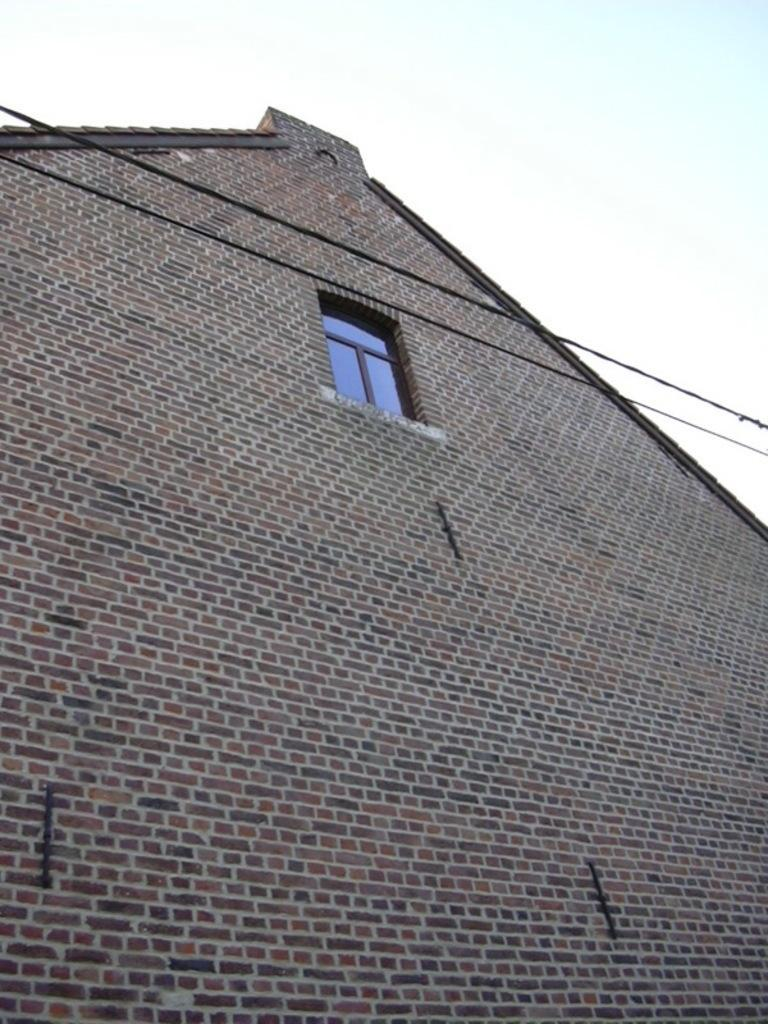What is the main subject of the image? The main subject of the image is a building. Can you describe the building in the image? The building has a window. What is visible at the top of the image? The sky is visible at the top of the image. What type of growth can be seen on the building in the image? There is no visible growth on the building in the image. What drug is being administered to the building in the image? There is no drug or any indication of drug administration in the image. 